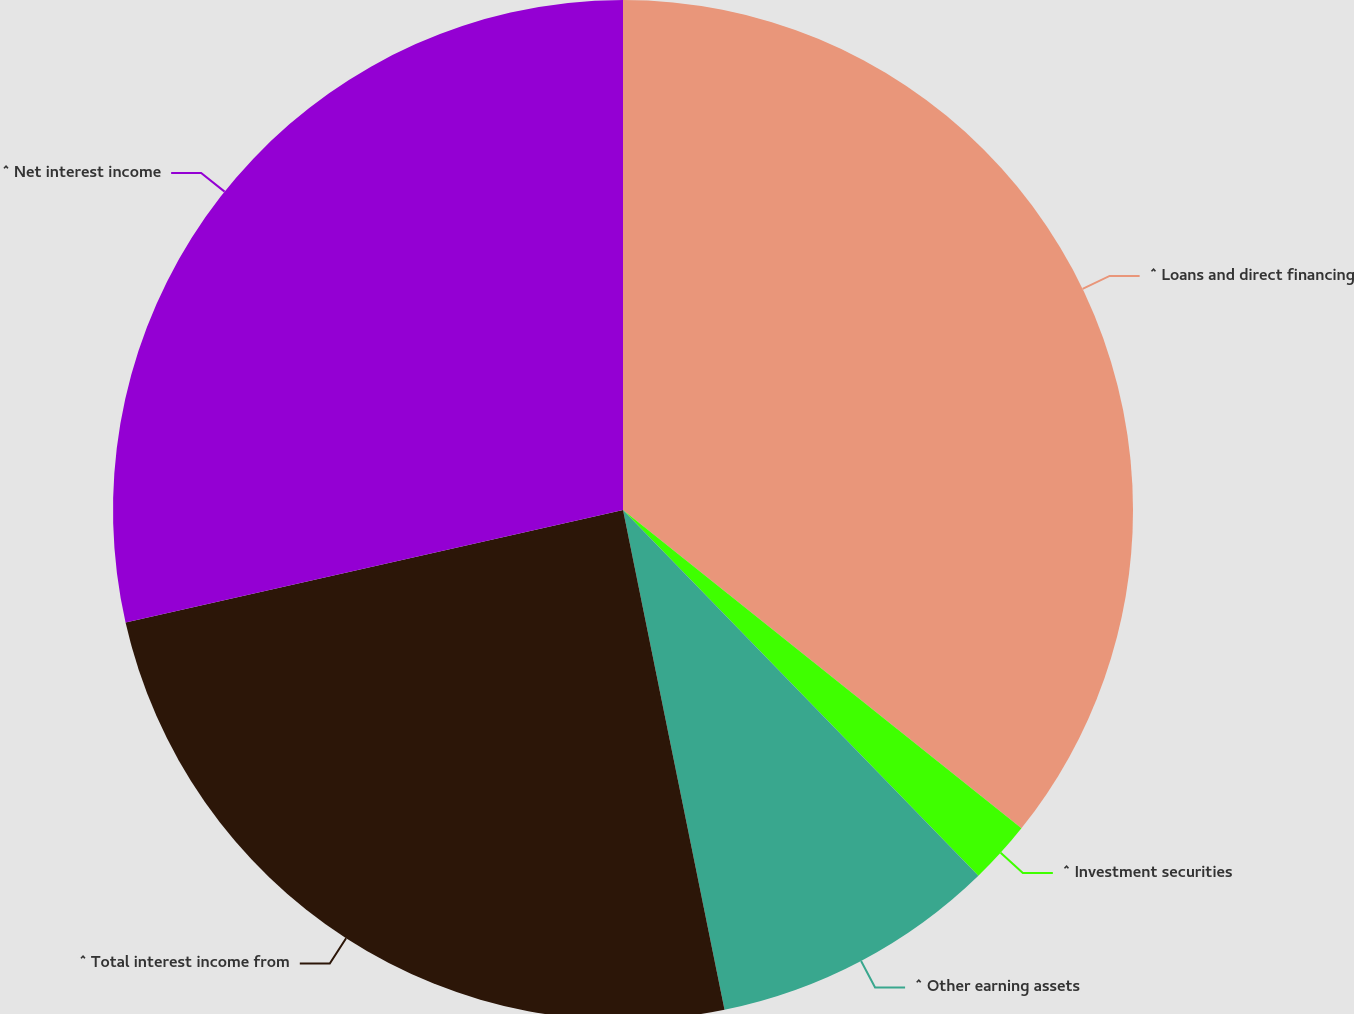<chart> <loc_0><loc_0><loc_500><loc_500><pie_chart><fcel>^ Loans and direct financing<fcel>^ Investment securities<fcel>^ Other earning assets<fcel>^ Total interest income from<fcel>^ Net interest income<nl><fcel>35.73%<fcel>2.0%<fcel>9.08%<fcel>24.65%<fcel>28.54%<nl></chart> 